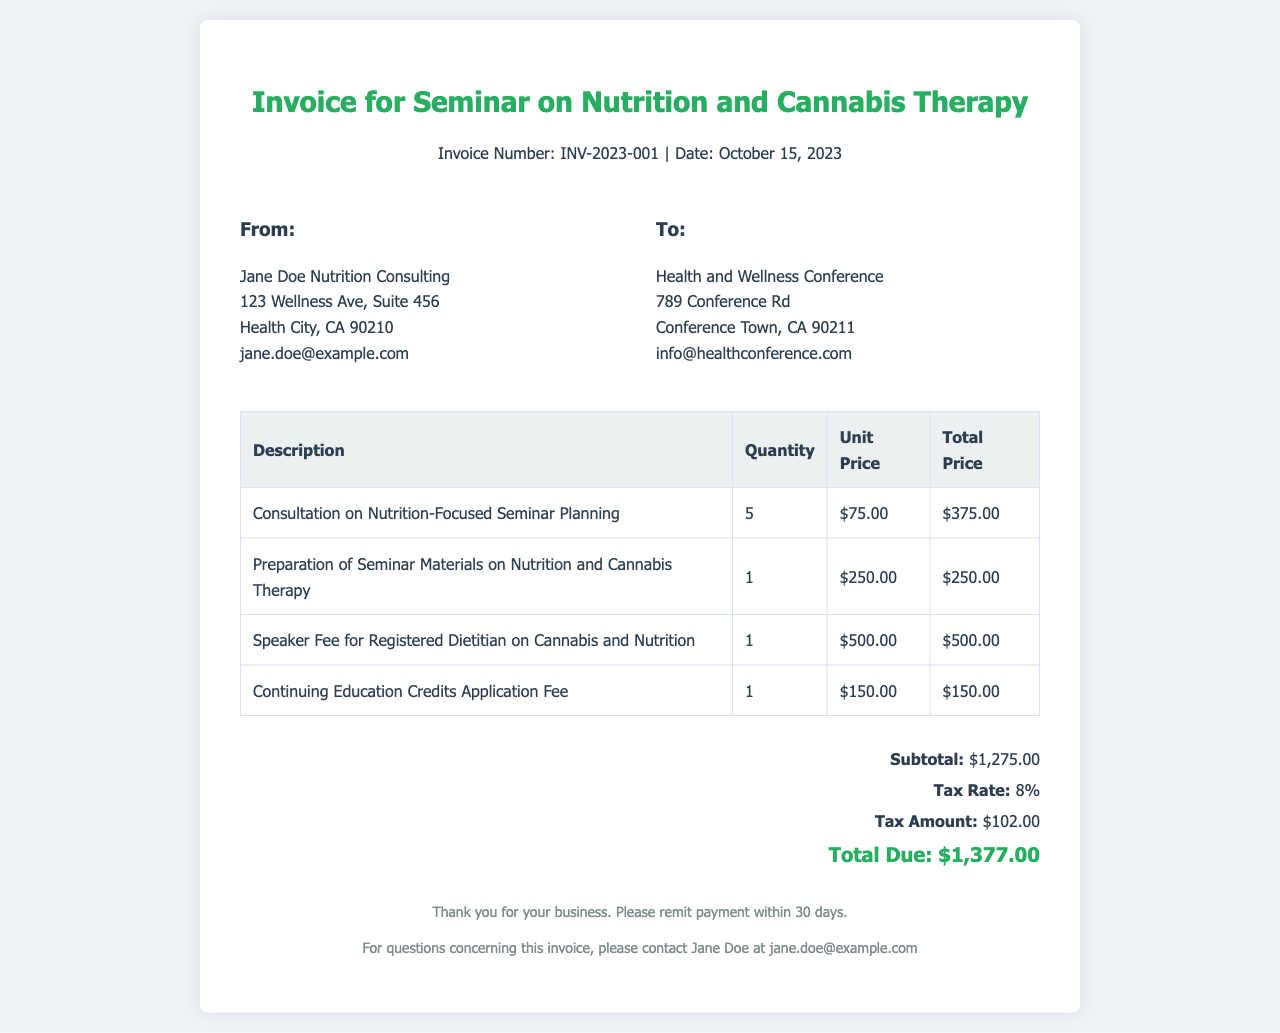What is the invoice number? The invoice number is explicitly stated in the document, which is used for tracking and reference purposes.
Answer: INV-2023-001 Who is the sender of the invoice? The sender's information, including name and contact details, is provided in the "From" section of the document.
Answer: Jane Doe Nutrition Consulting What is the subtotal amount? The subtotal is listed among the summary of fees and is calculated before tax is applied.
Answer: $1,275.00 What is the total due? The total amount due is calculated after adding tax to the subtotal and is clearly listed in the document.
Answer: $1,377.00 How many consultation sessions were included? The quantity of consultation sessions is listed alongside their description in the invoice table.
Answer: 5 What is the tax rate applied? The tax rate is specified in the document, indicating the percentage used to calculate the tax amount.
Answer: 8% What is the speaker fee? The document provides a detailed breakdown of fees, including the fee specifically for the speaker in the invoice table.
Answer: $500.00 What is the purpose of the invoice? The purpose of the invoice is indicated in the title, summarizing the services rendered for a specific event.
Answer: Seminar on Nutrition and Cannabis Therapy What is the due date for payment? The due date is implied by the instruction to remit payment within a specified timeframe.
Answer: Within 30 days 